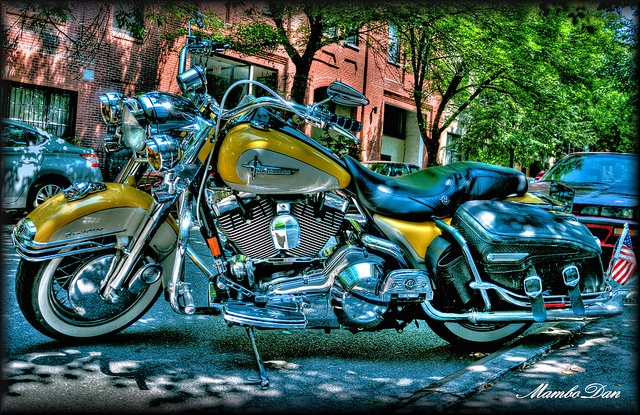Describe the objects in this image and their specific colors. I can see motorcycle in black and teal tones, car in black, teal, and lightblue tones, car in black, lightblue, and teal tones, and car in black, darkgreen, teal, and darkgray tones in this image. 